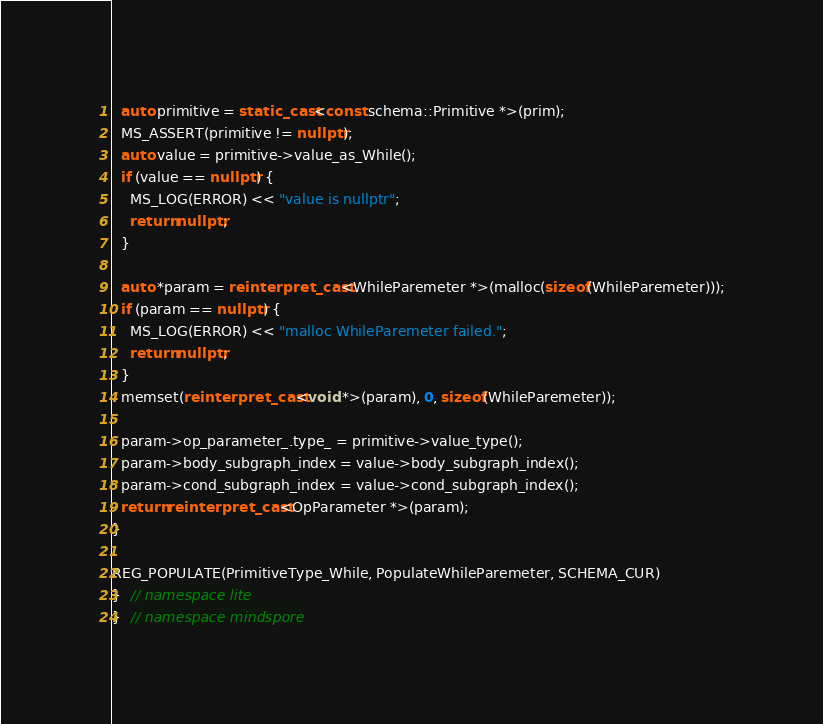<code> <loc_0><loc_0><loc_500><loc_500><_C++_>  auto primitive = static_cast<const schema::Primitive *>(prim);
  MS_ASSERT(primitive != nullptr);
  auto value = primitive->value_as_While();
  if (value == nullptr) {
    MS_LOG(ERROR) << "value is nullptr";
    return nullptr;
  }

  auto *param = reinterpret_cast<WhileParemeter *>(malloc(sizeof(WhileParemeter)));
  if (param == nullptr) {
    MS_LOG(ERROR) << "malloc WhileParemeter failed.";
    return nullptr;
  }
  memset(reinterpret_cast<void *>(param), 0, sizeof(WhileParemeter));

  param->op_parameter_.type_ = primitive->value_type();
  param->body_subgraph_index = value->body_subgraph_index();
  param->cond_subgraph_index = value->cond_subgraph_index();
  return reinterpret_cast<OpParameter *>(param);
}

REG_POPULATE(PrimitiveType_While, PopulateWhileParemeter, SCHEMA_CUR)
}  // namespace lite
}  // namespace mindspore
</code> 